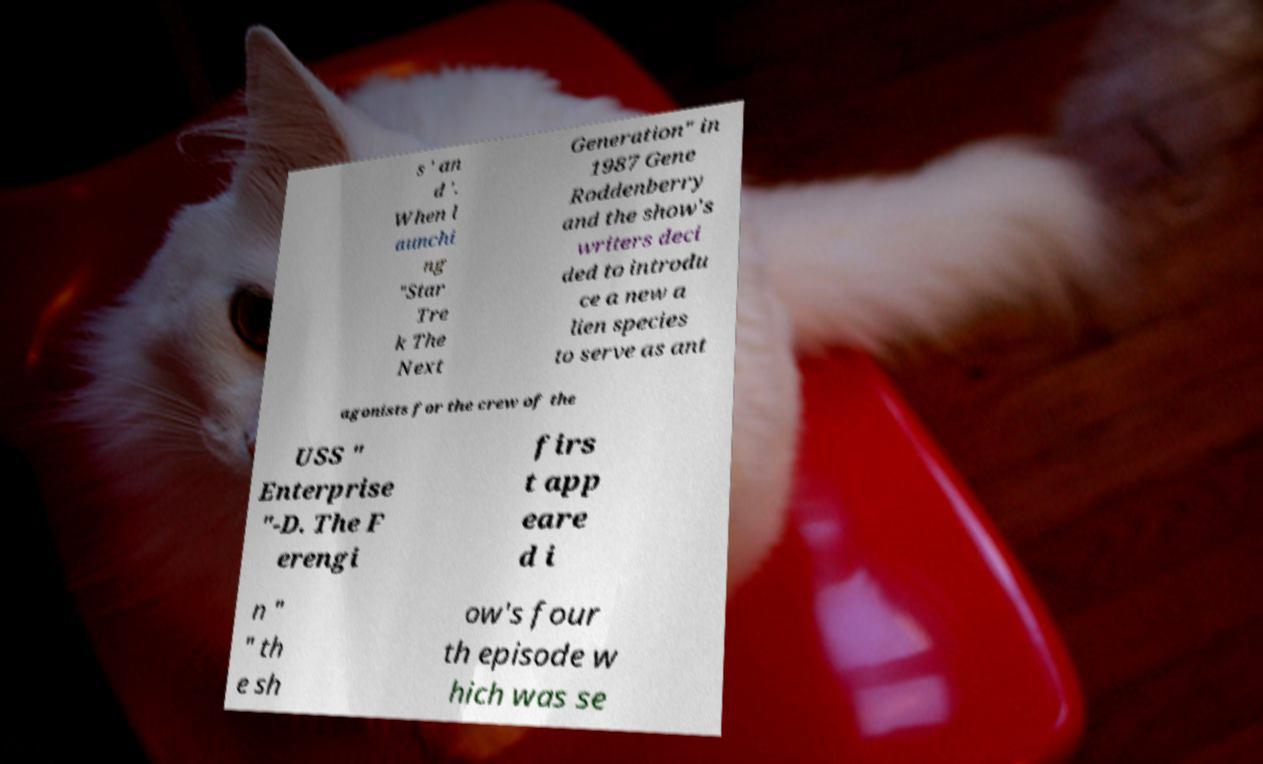There's text embedded in this image that I need extracted. Can you transcribe it verbatim? s ' an d '. When l aunchi ng "Star Tre k The Next Generation" in 1987 Gene Roddenberry and the show's writers deci ded to introdu ce a new a lien species to serve as ant agonists for the crew of the USS " Enterprise "-D. The F erengi firs t app eare d i n " " th e sh ow's four th episode w hich was se 